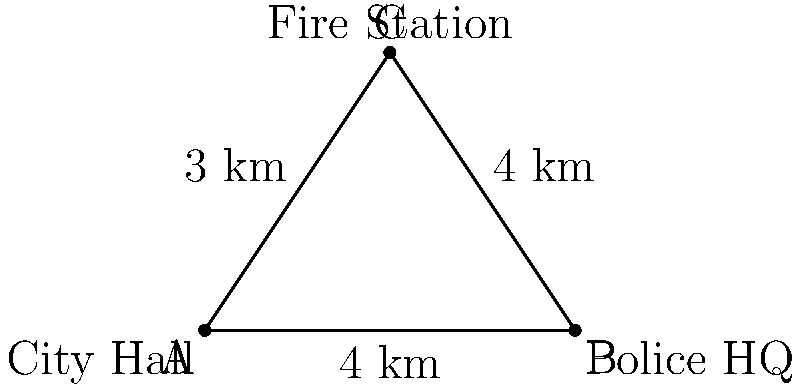In a proposed city plan, the City Hall, Police Headquarters, and Fire Station form a right-angled triangle. The distance between City Hall and Police HQ is 4 km, and the Fire Station is equidistant from both at 3 km. What is the measure of the angle between the roads connecting the Fire Station to the City Hall and Police HQ? Let's approach this step-by-step:

1) We have a right-angled triangle where:
   - City Hall is at point A
   - Police HQ is at point B
   - Fire Station is at point C
   - Angle CAB is a right angle (90°)

2) We know that:
   - AB = 4 km (distance between City Hall and Police HQ)
   - AC = CB = 3 km (Fire Station is equidistant from City Hall and Police HQ)

3) We need to find angle ACB. In a right-angled triangle, we can use the cosine function:

   $$\cos(ACB) = \frac{AC^2 + CB^2 - AB^2}{2(AC)(CB)}$$

4) Substituting the known values:

   $$\cos(ACB) = \frac{3^2 + 3^2 - 4^2}{2(3)(3)}$$

5) Simplify:

   $$\cos(ACB) = \frac{9 + 9 - 16}{18} = \frac{2}{18} = \frac{1}{9}$$

6) To find the angle, we take the inverse cosine (arccos):

   $$ACB = \arccos(\frac{1}{9})$$

7) Using a calculator or computer, we can find that:

   $$ACB \approx 83.62°$$

Therefore, the angle between the roads connecting the Fire Station to the City Hall and Police HQ is approximately 83.62°.
Answer: 83.62° 